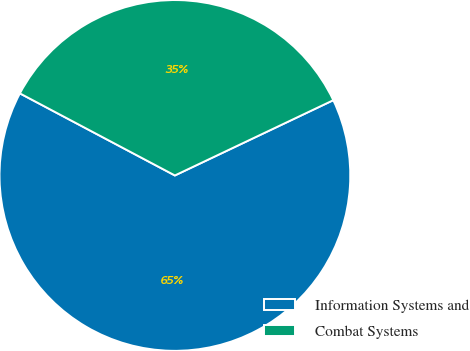Convert chart to OTSL. <chart><loc_0><loc_0><loc_500><loc_500><pie_chart><fcel>Information Systems and<fcel>Combat Systems<nl><fcel>64.81%<fcel>35.19%<nl></chart> 